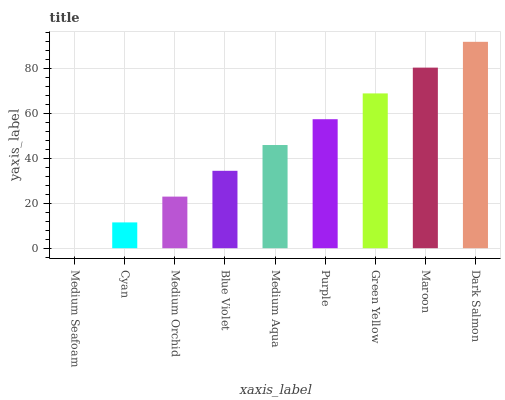Is Medium Seafoam the minimum?
Answer yes or no. Yes. Is Dark Salmon the maximum?
Answer yes or no. Yes. Is Cyan the minimum?
Answer yes or no. No. Is Cyan the maximum?
Answer yes or no. No. Is Cyan greater than Medium Seafoam?
Answer yes or no. Yes. Is Medium Seafoam less than Cyan?
Answer yes or no. Yes. Is Medium Seafoam greater than Cyan?
Answer yes or no. No. Is Cyan less than Medium Seafoam?
Answer yes or no. No. Is Medium Aqua the high median?
Answer yes or no. Yes. Is Medium Aqua the low median?
Answer yes or no. Yes. Is Green Yellow the high median?
Answer yes or no. No. Is Dark Salmon the low median?
Answer yes or no. No. 